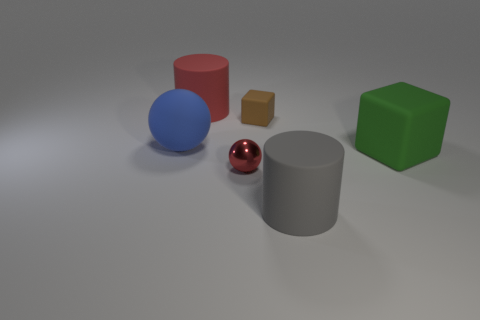Add 4 big cubes. How many objects exist? 10 Subtract all cylinders. How many objects are left? 4 Subtract 0 yellow cubes. How many objects are left? 6 Subtract all tiny red blocks. Subtract all small red metal things. How many objects are left? 5 Add 2 tiny red objects. How many tiny red objects are left? 3 Add 3 tiny red spheres. How many tiny red spheres exist? 4 